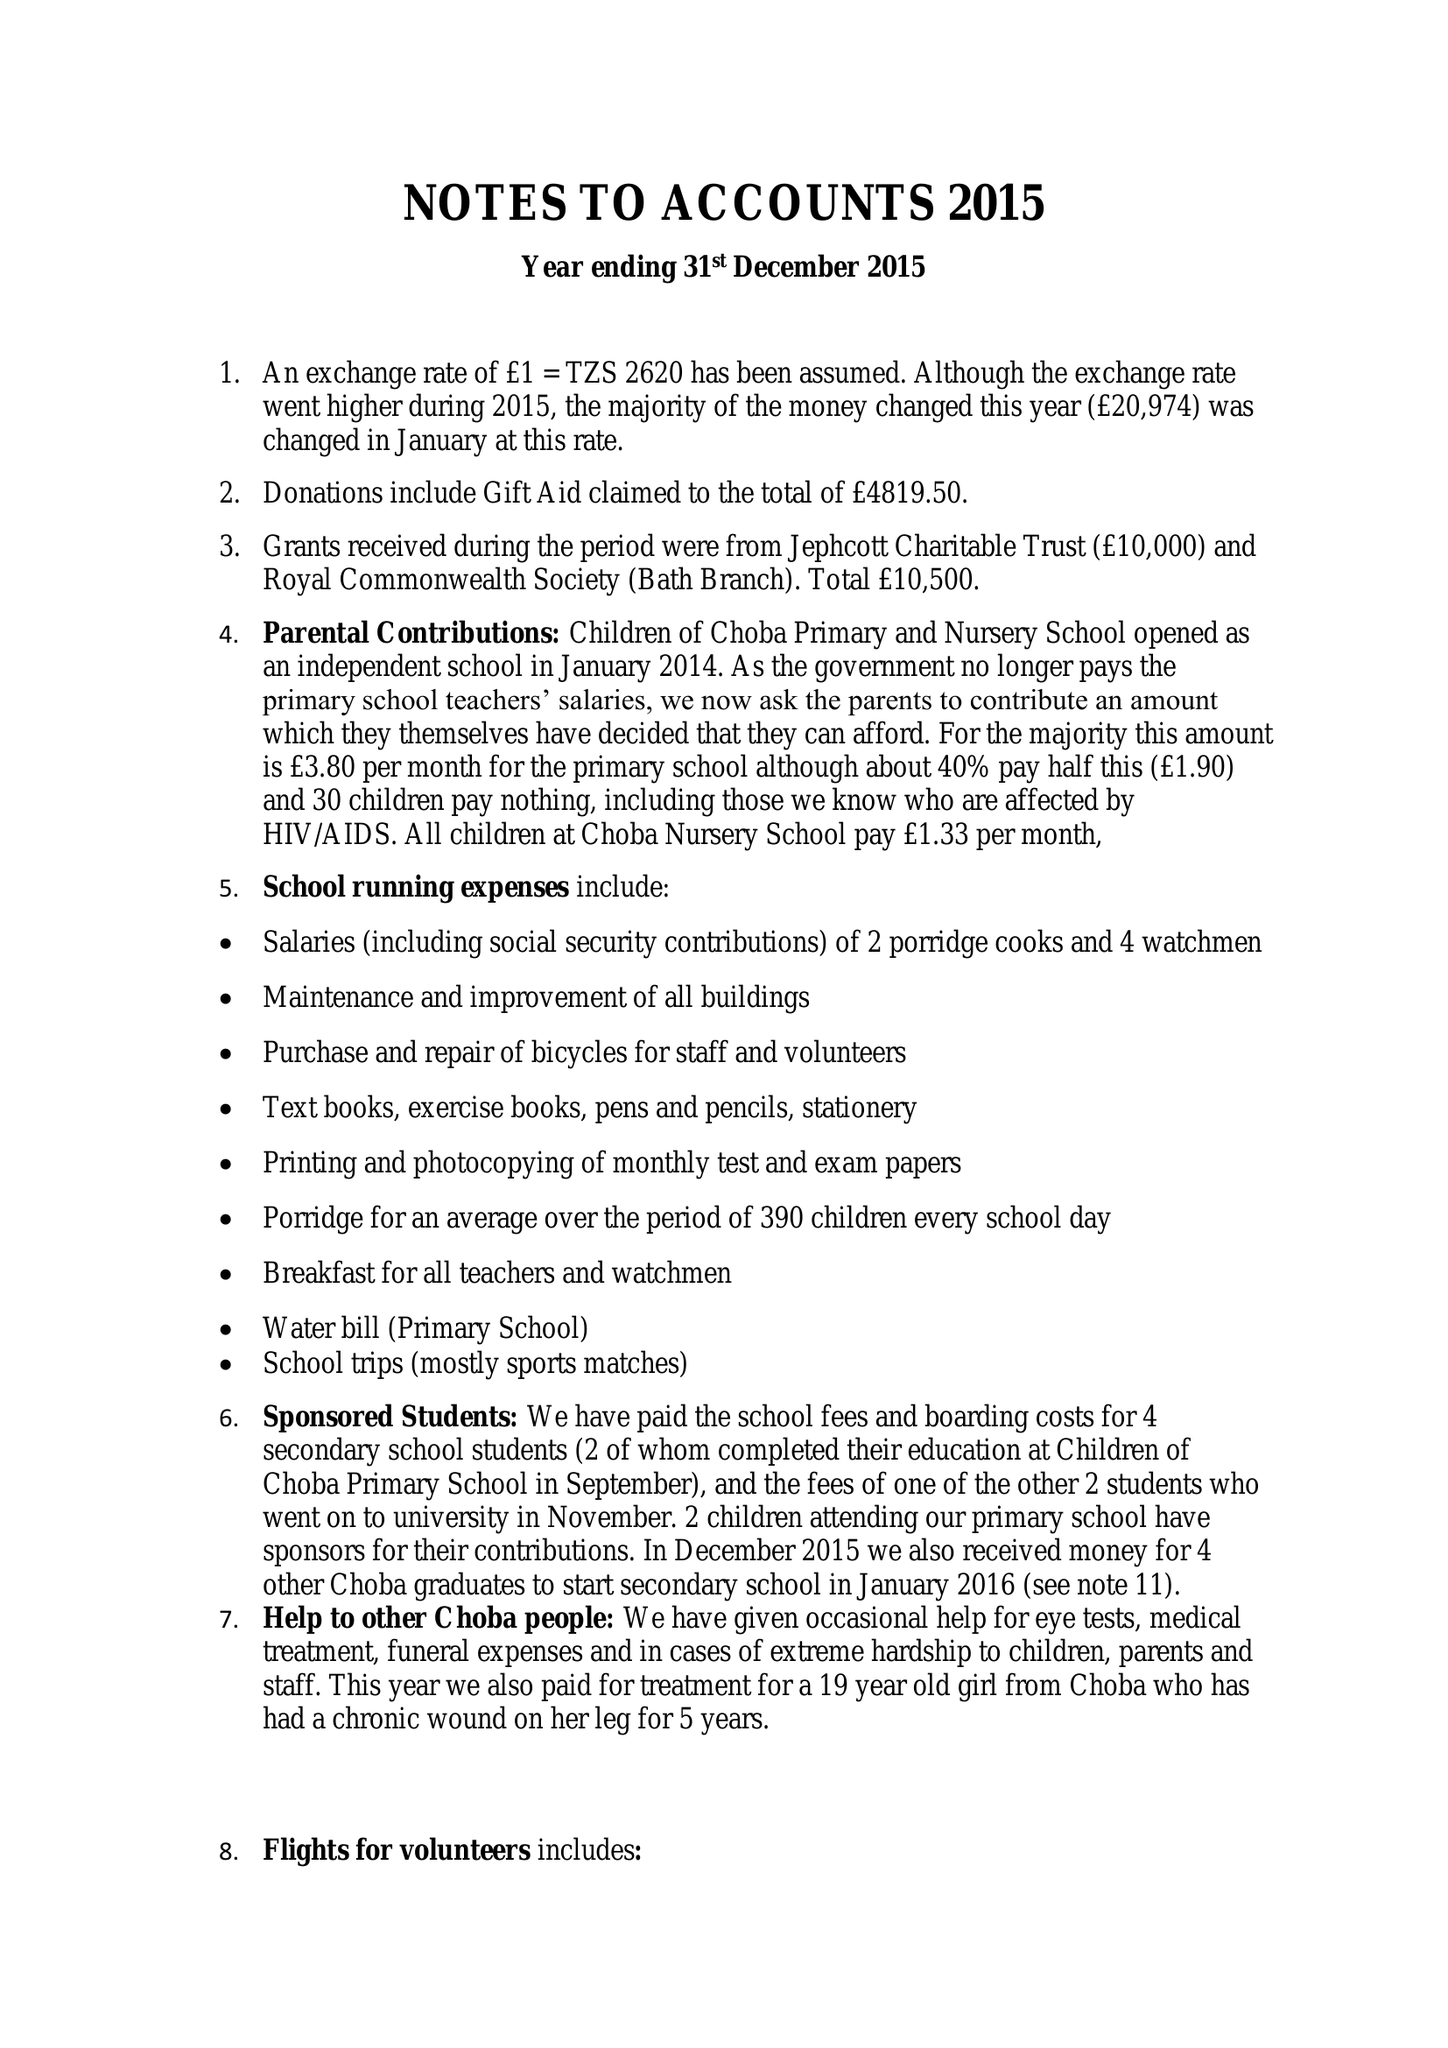What is the value for the charity_number?
Answer the question using a single word or phrase. 1138096 